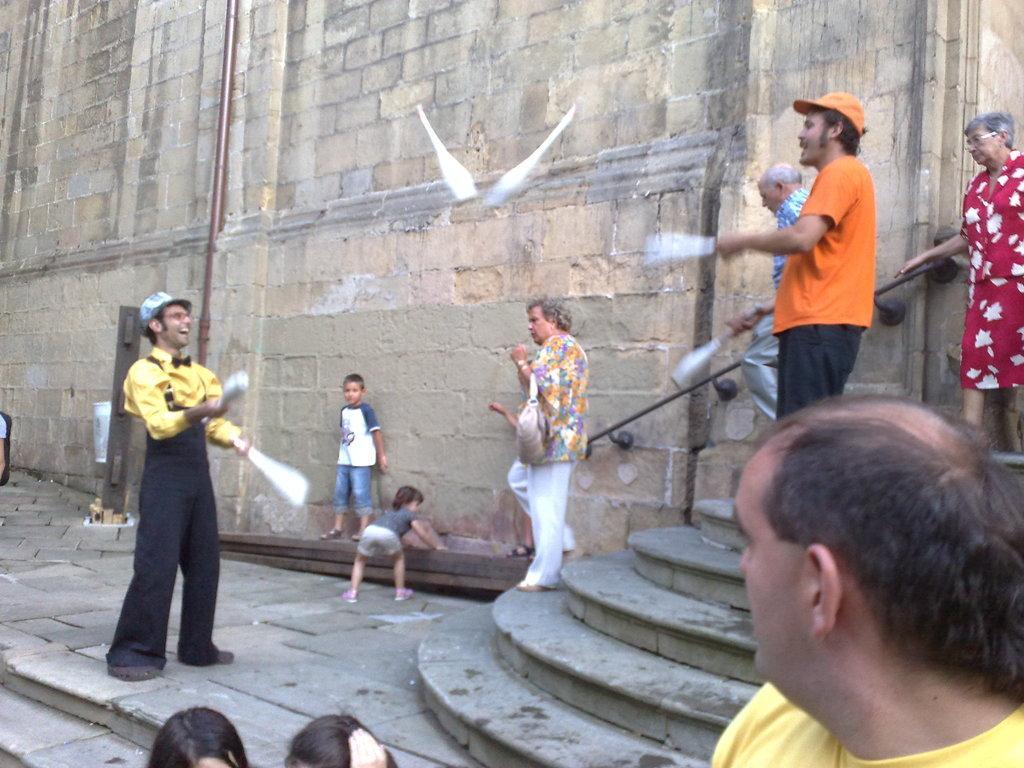Describe this image in one or two sentences. In this image there are two persons throwing bottles, in the background there are people walking on steps and there is a wall near the wall there are children's. 